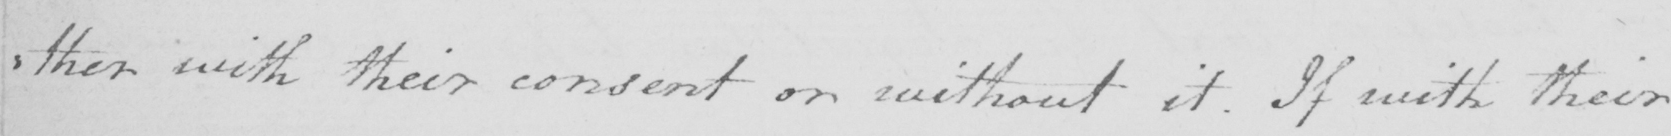Can you tell me what this handwritten text says? : ther with their consent or without it . If with their 